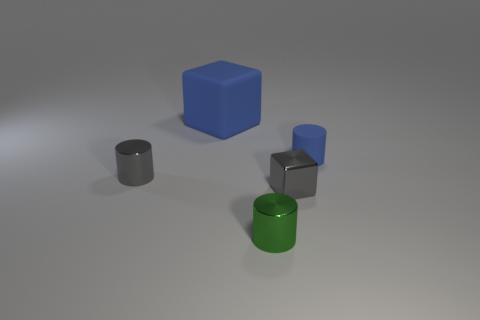There is a blue thing behind the blue matte object on the right side of the green cylinder; how big is it?
Keep it short and to the point. Large. There is a cylinder right of the small green thing; how big is it?
Give a very brief answer. Small. Are there fewer small green cylinders right of the tiny green cylinder than tiny metallic cylinders that are left of the large blue rubber thing?
Keep it short and to the point. Yes. What is the color of the matte cylinder?
Provide a succinct answer. Blue. Is there a rubber thing that has the same color as the shiny block?
Your response must be concise. No. What shape is the tiny metallic object that is in front of the tiny gray shiny object that is in front of the gray thing left of the large rubber cube?
Your response must be concise. Cylinder. There is a object that is behind the tiny blue matte object; what material is it?
Your answer should be very brief. Rubber. There is a metal cylinder in front of the thing on the left side of the thing behind the tiny matte cylinder; what is its size?
Offer a terse response. Small. There is a green cylinder; is it the same size as the gray object to the right of the gray metallic cylinder?
Your answer should be compact. Yes. There is a rubber thing that is behind the matte cylinder; what is its color?
Make the answer very short. Blue. 